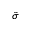<formula> <loc_0><loc_0><loc_500><loc_500>\tilde { \sigma }</formula> 